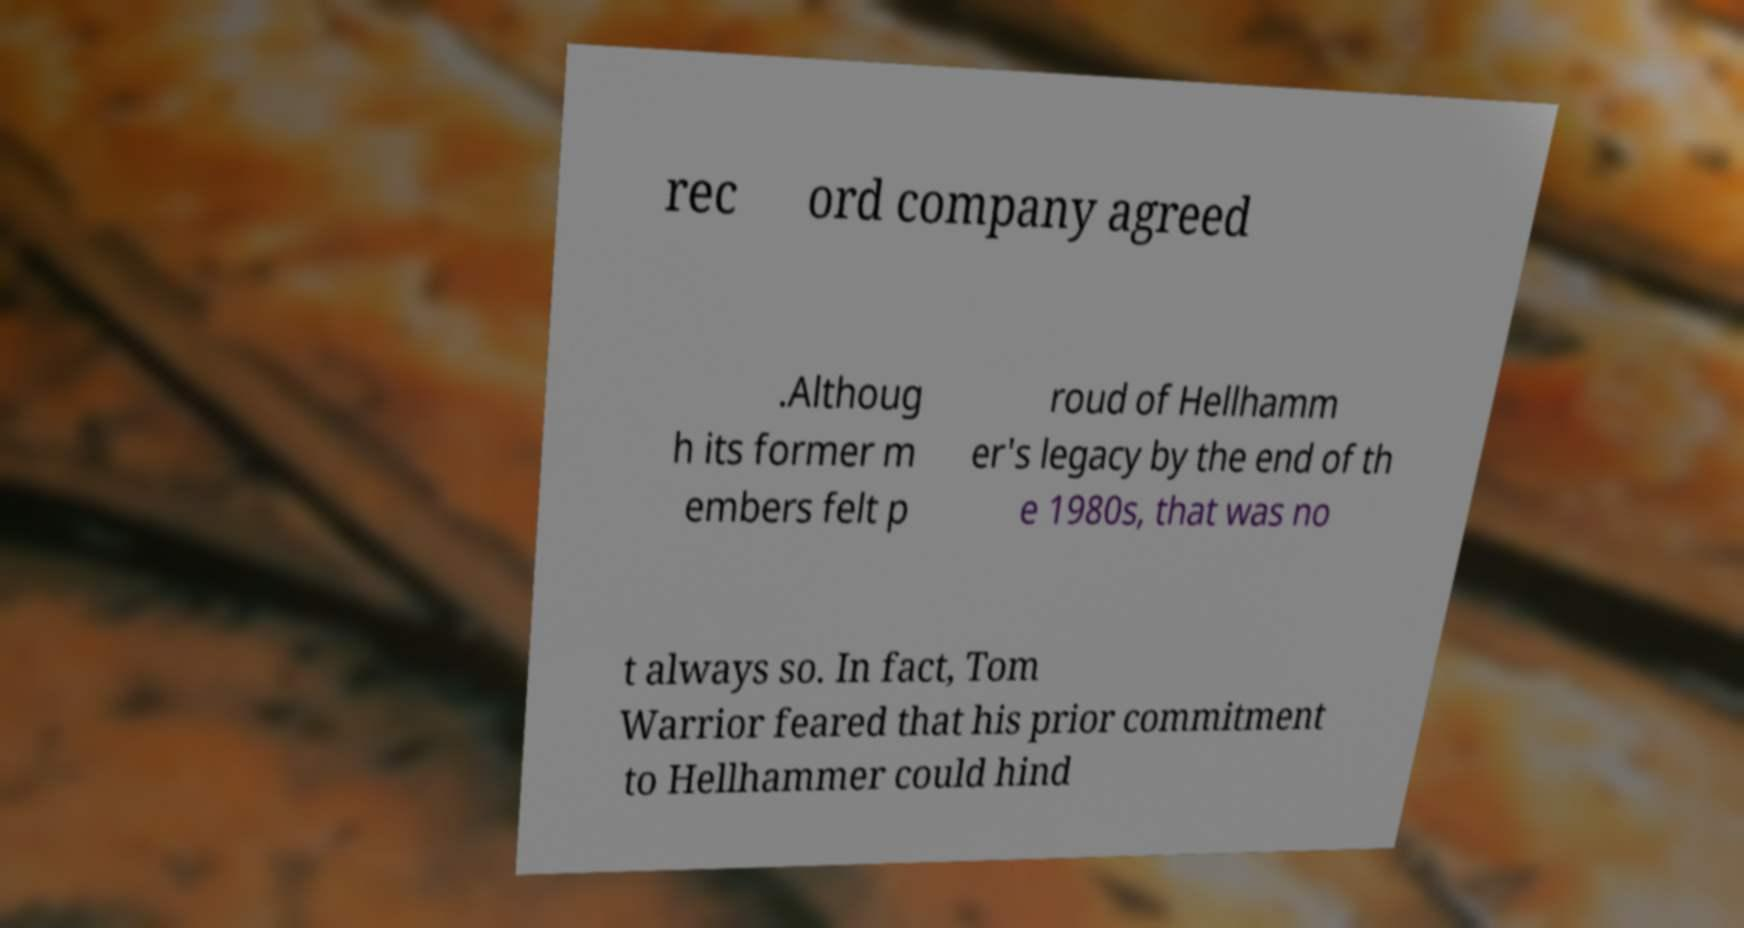Please read and relay the text visible in this image. What does it say? rec ord company agreed .Althoug h its former m embers felt p roud of Hellhamm er's legacy by the end of th e 1980s, that was no t always so. In fact, Tom Warrior feared that his prior commitment to Hellhammer could hind 